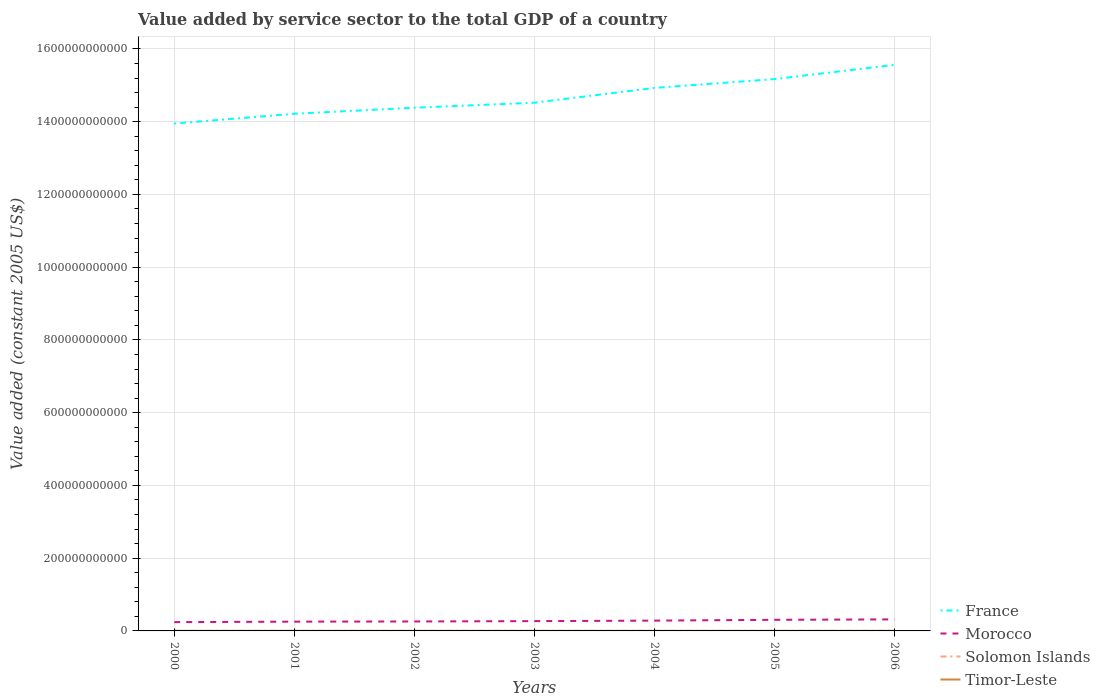Does the line corresponding to France intersect with the line corresponding to Morocco?
Make the answer very short. No. Is the number of lines equal to the number of legend labels?
Make the answer very short. Yes. Across all years, what is the maximum value added by service sector in Solomon Islands?
Provide a succinct answer. 1.94e+08. What is the total value added by service sector in France in the graph?
Your response must be concise. -5.44e+1. What is the difference between the highest and the second highest value added by service sector in Timor-Leste?
Provide a succinct answer. 7.10e+07. What is the difference between the highest and the lowest value added by service sector in France?
Your answer should be very brief. 3. How many years are there in the graph?
Make the answer very short. 7. What is the difference between two consecutive major ticks on the Y-axis?
Give a very brief answer. 2.00e+11. Does the graph contain grids?
Ensure brevity in your answer.  Yes. Where does the legend appear in the graph?
Your answer should be compact. Bottom right. How are the legend labels stacked?
Make the answer very short. Vertical. What is the title of the graph?
Give a very brief answer. Value added by service sector to the total GDP of a country. What is the label or title of the X-axis?
Your answer should be compact. Years. What is the label or title of the Y-axis?
Make the answer very short. Value added (constant 2005 US$). What is the Value added (constant 2005 US$) in France in 2000?
Keep it short and to the point. 1.39e+12. What is the Value added (constant 2005 US$) of Morocco in 2000?
Make the answer very short. 2.42e+1. What is the Value added (constant 2005 US$) of Solomon Islands in 2000?
Keep it short and to the point. 2.48e+08. What is the Value added (constant 2005 US$) of Timor-Leste in 2000?
Your response must be concise. 2.26e+08. What is the Value added (constant 2005 US$) in France in 2001?
Offer a very short reply. 1.42e+12. What is the Value added (constant 2005 US$) of Morocco in 2001?
Provide a short and direct response. 2.55e+1. What is the Value added (constant 2005 US$) in Solomon Islands in 2001?
Your answer should be very brief. 2.35e+08. What is the Value added (constant 2005 US$) of Timor-Leste in 2001?
Ensure brevity in your answer.  2.95e+08. What is the Value added (constant 2005 US$) of France in 2002?
Provide a short and direct response. 1.44e+12. What is the Value added (constant 2005 US$) in Morocco in 2002?
Give a very brief answer. 2.60e+1. What is the Value added (constant 2005 US$) of Solomon Islands in 2002?
Ensure brevity in your answer.  2.09e+08. What is the Value added (constant 2005 US$) of Timor-Leste in 2002?
Your answer should be compact. 2.65e+08. What is the Value added (constant 2005 US$) in France in 2003?
Provide a short and direct response. 1.45e+12. What is the Value added (constant 2005 US$) of Morocco in 2003?
Keep it short and to the point. 2.69e+1. What is the Value added (constant 2005 US$) of Solomon Islands in 2003?
Keep it short and to the point. 1.94e+08. What is the Value added (constant 2005 US$) of Timor-Leste in 2003?
Make the answer very short. 2.63e+08. What is the Value added (constant 2005 US$) of France in 2004?
Provide a succinct answer. 1.49e+12. What is the Value added (constant 2005 US$) in Morocco in 2004?
Provide a short and direct response. 2.83e+1. What is the Value added (constant 2005 US$) of Solomon Islands in 2004?
Ensure brevity in your answer.  2.15e+08. What is the Value added (constant 2005 US$) in Timor-Leste in 2004?
Your response must be concise. 2.73e+08. What is the Value added (constant 2005 US$) of France in 2005?
Your response must be concise. 1.52e+12. What is the Value added (constant 2005 US$) of Morocco in 2005?
Your answer should be compact. 3.05e+1. What is the Value added (constant 2005 US$) of Solomon Islands in 2005?
Your response must be concise. 2.33e+08. What is the Value added (constant 2005 US$) in Timor-Leste in 2005?
Provide a short and direct response. 2.97e+08. What is the Value added (constant 2005 US$) of France in 2006?
Offer a very short reply. 1.56e+12. What is the Value added (constant 2005 US$) of Morocco in 2006?
Your response must be concise. 3.17e+1. What is the Value added (constant 2005 US$) in Solomon Islands in 2006?
Provide a succinct answer. 2.52e+08. What is the Value added (constant 2005 US$) in Timor-Leste in 2006?
Provide a short and direct response. 2.89e+08. Across all years, what is the maximum Value added (constant 2005 US$) in France?
Keep it short and to the point. 1.56e+12. Across all years, what is the maximum Value added (constant 2005 US$) in Morocco?
Give a very brief answer. 3.17e+1. Across all years, what is the maximum Value added (constant 2005 US$) of Solomon Islands?
Offer a very short reply. 2.52e+08. Across all years, what is the maximum Value added (constant 2005 US$) of Timor-Leste?
Provide a short and direct response. 2.97e+08. Across all years, what is the minimum Value added (constant 2005 US$) of France?
Ensure brevity in your answer.  1.39e+12. Across all years, what is the minimum Value added (constant 2005 US$) in Morocco?
Give a very brief answer. 2.42e+1. Across all years, what is the minimum Value added (constant 2005 US$) in Solomon Islands?
Provide a short and direct response. 1.94e+08. Across all years, what is the minimum Value added (constant 2005 US$) in Timor-Leste?
Make the answer very short. 2.26e+08. What is the total Value added (constant 2005 US$) in France in the graph?
Offer a very short reply. 1.03e+13. What is the total Value added (constant 2005 US$) of Morocco in the graph?
Your response must be concise. 1.93e+11. What is the total Value added (constant 2005 US$) in Solomon Islands in the graph?
Provide a short and direct response. 1.59e+09. What is the total Value added (constant 2005 US$) in Timor-Leste in the graph?
Your answer should be very brief. 1.91e+09. What is the difference between the Value added (constant 2005 US$) of France in 2000 and that in 2001?
Make the answer very short. -2.69e+1. What is the difference between the Value added (constant 2005 US$) of Morocco in 2000 and that in 2001?
Make the answer very short. -1.34e+09. What is the difference between the Value added (constant 2005 US$) of Solomon Islands in 2000 and that in 2001?
Provide a succinct answer. 1.31e+07. What is the difference between the Value added (constant 2005 US$) of Timor-Leste in 2000 and that in 2001?
Ensure brevity in your answer.  -6.95e+07. What is the difference between the Value added (constant 2005 US$) in France in 2000 and that in 2002?
Provide a short and direct response. -4.36e+1. What is the difference between the Value added (constant 2005 US$) in Morocco in 2000 and that in 2002?
Offer a very short reply. -1.79e+09. What is the difference between the Value added (constant 2005 US$) of Solomon Islands in 2000 and that in 2002?
Provide a short and direct response. 3.97e+07. What is the difference between the Value added (constant 2005 US$) in Timor-Leste in 2000 and that in 2002?
Offer a terse response. -3.89e+07. What is the difference between the Value added (constant 2005 US$) of France in 2000 and that in 2003?
Ensure brevity in your answer.  -5.73e+1. What is the difference between the Value added (constant 2005 US$) of Morocco in 2000 and that in 2003?
Provide a succinct answer. -2.75e+09. What is the difference between the Value added (constant 2005 US$) of Solomon Islands in 2000 and that in 2003?
Ensure brevity in your answer.  5.41e+07. What is the difference between the Value added (constant 2005 US$) of Timor-Leste in 2000 and that in 2003?
Your response must be concise. -3.66e+07. What is the difference between the Value added (constant 2005 US$) in France in 2000 and that in 2004?
Ensure brevity in your answer.  -9.79e+1. What is the difference between the Value added (constant 2005 US$) in Morocco in 2000 and that in 2004?
Give a very brief answer. -4.18e+09. What is the difference between the Value added (constant 2005 US$) of Solomon Islands in 2000 and that in 2004?
Your response must be concise. 3.31e+07. What is the difference between the Value added (constant 2005 US$) in Timor-Leste in 2000 and that in 2004?
Your answer should be very brief. -4.66e+07. What is the difference between the Value added (constant 2005 US$) in France in 2000 and that in 2005?
Ensure brevity in your answer.  -1.22e+11. What is the difference between the Value added (constant 2005 US$) in Morocco in 2000 and that in 2005?
Keep it short and to the point. -6.36e+09. What is the difference between the Value added (constant 2005 US$) of Solomon Islands in 2000 and that in 2005?
Your answer should be very brief. 1.53e+07. What is the difference between the Value added (constant 2005 US$) of Timor-Leste in 2000 and that in 2005?
Your answer should be very brief. -7.10e+07. What is the difference between the Value added (constant 2005 US$) in France in 2000 and that in 2006?
Give a very brief answer. -1.61e+11. What is the difference between the Value added (constant 2005 US$) in Morocco in 2000 and that in 2006?
Your answer should be compact. -7.53e+09. What is the difference between the Value added (constant 2005 US$) in Solomon Islands in 2000 and that in 2006?
Give a very brief answer. -3.08e+06. What is the difference between the Value added (constant 2005 US$) of Timor-Leste in 2000 and that in 2006?
Your answer should be compact. -6.34e+07. What is the difference between the Value added (constant 2005 US$) in France in 2001 and that in 2002?
Offer a very short reply. -1.67e+1. What is the difference between the Value added (constant 2005 US$) of Morocco in 2001 and that in 2002?
Give a very brief answer. -4.57e+08. What is the difference between the Value added (constant 2005 US$) in Solomon Islands in 2001 and that in 2002?
Provide a succinct answer. 2.66e+07. What is the difference between the Value added (constant 2005 US$) in Timor-Leste in 2001 and that in 2002?
Offer a terse response. 3.05e+07. What is the difference between the Value added (constant 2005 US$) in France in 2001 and that in 2003?
Provide a short and direct response. -3.04e+1. What is the difference between the Value added (constant 2005 US$) of Morocco in 2001 and that in 2003?
Keep it short and to the point. -1.41e+09. What is the difference between the Value added (constant 2005 US$) in Solomon Islands in 2001 and that in 2003?
Provide a succinct answer. 4.10e+07. What is the difference between the Value added (constant 2005 US$) in Timor-Leste in 2001 and that in 2003?
Your answer should be very brief. 3.28e+07. What is the difference between the Value added (constant 2005 US$) of France in 2001 and that in 2004?
Ensure brevity in your answer.  -7.10e+1. What is the difference between the Value added (constant 2005 US$) in Morocco in 2001 and that in 2004?
Ensure brevity in your answer.  -2.84e+09. What is the difference between the Value added (constant 2005 US$) of Solomon Islands in 2001 and that in 2004?
Offer a terse response. 2.00e+07. What is the difference between the Value added (constant 2005 US$) of Timor-Leste in 2001 and that in 2004?
Ensure brevity in your answer.  2.29e+07. What is the difference between the Value added (constant 2005 US$) of France in 2001 and that in 2005?
Offer a very short reply. -9.54e+1. What is the difference between the Value added (constant 2005 US$) of Morocco in 2001 and that in 2005?
Your response must be concise. -5.02e+09. What is the difference between the Value added (constant 2005 US$) in Solomon Islands in 2001 and that in 2005?
Provide a short and direct response. 2.29e+06. What is the difference between the Value added (constant 2005 US$) in Timor-Leste in 2001 and that in 2005?
Your answer should be very brief. -1.53e+06. What is the difference between the Value added (constant 2005 US$) of France in 2001 and that in 2006?
Offer a very short reply. -1.34e+11. What is the difference between the Value added (constant 2005 US$) of Morocco in 2001 and that in 2006?
Your answer should be compact. -6.20e+09. What is the difference between the Value added (constant 2005 US$) in Solomon Islands in 2001 and that in 2006?
Provide a succinct answer. -1.61e+07. What is the difference between the Value added (constant 2005 US$) in Timor-Leste in 2001 and that in 2006?
Your response must be concise. 6.11e+06. What is the difference between the Value added (constant 2005 US$) of France in 2002 and that in 2003?
Provide a succinct answer. -1.37e+1. What is the difference between the Value added (constant 2005 US$) of Morocco in 2002 and that in 2003?
Your answer should be compact. -9.53e+08. What is the difference between the Value added (constant 2005 US$) of Solomon Islands in 2002 and that in 2003?
Keep it short and to the point. 1.44e+07. What is the difference between the Value added (constant 2005 US$) in Timor-Leste in 2002 and that in 2003?
Give a very brief answer. 2.29e+06. What is the difference between the Value added (constant 2005 US$) in France in 2002 and that in 2004?
Offer a terse response. -5.44e+1. What is the difference between the Value added (constant 2005 US$) of Morocco in 2002 and that in 2004?
Your answer should be compact. -2.38e+09. What is the difference between the Value added (constant 2005 US$) in Solomon Islands in 2002 and that in 2004?
Provide a short and direct response. -6.61e+06. What is the difference between the Value added (constant 2005 US$) in Timor-Leste in 2002 and that in 2004?
Your answer should be compact. -7.63e+06. What is the difference between the Value added (constant 2005 US$) in France in 2002 and that in 2005?
Your answer should be very brief. -7.87e+1. What is the difference between the Value added (constant 2005 US$) in Morocco in 2002 and that in 2005?
Your answer should be compact. -4.56e+09. What is the difference between the Value added (constant 2005 US$) of Solomon Islands in 2002 and that in 2005?
Make the answer very short. -2.43e+07. What is the difference between the Value added (constant 2005 US$) of Timor-Leste in 2002 and that in 2005?
Provide a succinct answer. -3.21e+07. What is the difference between the Value added (constant 2005 US$) in France in 2002 and that in 2006?
Your answer should be very brief. -1.18e+11. What is the difference between the Value added (constant 2005 US$) in Morocco in 2002 and that in 2006?
Provide a succinct answer. -5.74e+09. What is the difference between the Value added (constant 2005 US$) in Solomon Islands in 2002 and that in 2006?
Ensure brevity in your answer.  -4.28e+07. What is the difference between the Value added (constant 2005 US$) of Timor-Leste in 2002 and that in 2006?
Your response must be concise. -2.44e+07. What is the difference between the Value added (constant 2005 US$) in France in 2003 and that in 2004?
Your response must be concise. -4.07e+1. What is the difference between the Value added (constant 2005 US$) of Morocco in 2003 and that in 2004?
Provide a short and direct response. -1.43e+09. What is the difference between the Value added (constant 2005 US$) of Solomon Islands in 2003 and that in 2004?
Give a very brief answer. -2.10e+07. What is the difference between the Value added (constant 2005 US$) of Timor-Leste in 2003 and that in 2004?
Your response must be concise. -9.93e+06. What is the difference between the Value added (constant 2005 US$) of France in 2003 and that in 2005?
Your answer should be compact. -6.50e+1. What is the difference between the Value added (constant 2005 US$) of Morocco in 2003 and that in 2005?
Offer a terse response. -3.61e+09. What is the difference between the Value added (constant 2005 US$) of Solomon Islands in 2003 and that in 2005?
Your answer should be very brief. -3.87e+07. What is the difference between the Value added (constant 2005 US$) in Timor-Leste in 2003 and that in 2005?
Offer a terse response. -3.44e+07. What is the difference between the Value added (constant 2005 US$) in France in 2003 and that in 2006?
Offer a terse response. -1.04e+11. What is the difference between the Value added (constant 2005 US$) in Morocco in 2003 and that in 2006?
Provide a succinct answer. -4.79e+09. What is the difference between the Value added (constant 2005 US$) of Solomon Islands in 2003 and that in 2006?
Your answer should be compact. -5.72e+07. What is the difference between the Value added (constant 2005 US$) of Timor-Leste in 2003 and that in 2006?
Ensure brevity in your answer.  -2.67e+07. What is the difference between the Value added (constant 2005 US$) of France in 2004 and that in 2005?
Your answer should be compact. -2.43e+1. What is the difference between the Value added (constant 2005 US$) of Morocco in 2004 and that in 2005?
Keep it short and to the point. -2.18e+09. What is the difference between the Value added (constant 2005 US$) in Solomon Islands in 2004 and that in 2005?
Keep it short and to the point. -1.77e+07. What is the difference between the Value added (constant 2005 US$) in Timor-Leste in 2004 and that in 2005?
Keep it short and to the point. -2.44e+07. What is the difference between the Value added (constant 2005 US$) of France in 2004 and that in 2006?
Your answer should be very brief. -6.34e+1. What is the difference between the Value added (constant 2005 US$) in Morocco in 2004 and that in 2006?
Keep it short and to the point. -3.36e+09. What is the difference between the Value added (constant 2005 US$) of Solomon Islands in 2004 and that in 2006?
Provide a succinct answer. -3.62e+07. What is the difference between the Value added (constant 2005 US$) in Timor-Leste in 2004 and that in 2006?
Offer a very short reply. -1.68e+07. What is the difference between the Value added (constant 2005 US$) of France in 2005 and that in 2006?
Your response must be concise. -3.91e+1. What is the difference between the Value added (constant 2005 US$) in Morocco in 2005 and that in 2006?
Your answer should be very brief. -1.18e+09. What is the difference between the Value added (constant 2005 US$) in Solomon Islands in 2005 and that in 2006?
Provide a succinct answer. -1.84e+07. What is the difference between the Value added (constant 2005 US$) in Timor-Leste in 2005 and that in 2006?
Give a very brief answer. 7.63e+06. What is the difference between the Value added (constant 2005 US$) in France in 2000 and the Value added (constant 2005 US$) in Morocco in 2001?
Offer a terse response. 1.37e+12. What is the difference between the Value added (constant 2005 US$) in France in 2000 and the Value added (constant 2005 US$) in Solomon Islands in 2001?
Provide a short and direct response. 1.39e+12. What is the difference between the Value added (constant 2005 US$) in France in 2000 and the Value added (constant 2005 US$) in Timor-Leste in 2001?
Keep it short and to the point. 1.39e+12. What is the difference between the Value added (constant 2005 US$) of Morocco in 2000 and the Value added (constant 2005 US$) of Solomon Islands in 2001?
Your response must be concise. 2.39e+1. What is the difference between the Value added (constant 2005 US$) of Morocco in 2000 and the Value added (constant 2005 US$) of Timor-Leste in 2001?
Ensure brevity in your answer.  2.39e+1. What is the difference between the Value added (constant 2005 US$) in Solomon Islands in 2000 and the Value added (constant 2005 US$) in Timor-Leste in 2001?
Your answer should be very brief. -4.70e+07. What is the difference between the Value added (constant 2005 US$) of France in 2000 and the Value added (constant 2005 US$) of Morocco in 2002?
Provide a succinct answer. 1.37e+12. What is the difference between the Value added (constant 2005 US$) in France in 2000 and the Value added (constant 2005 US$) in Solomon Islands in 2002?
Your answer should be compact. 1.39e+12. What is the difference between the Value added (constant 2005 US$) in France in 2000 and the Value added (constant 2005 US$) in Timor-Leste in 2002?
Offer a terse response. 1.39e+12. What is the difference between the Value added (constant 2005 US$) of Morocco in 2000 and the Value added (constant 2005 US$) of Solomon Islands in 2002?
Provide a succinct answer. 2.40e+1. What is the difference between the Value added (constant 2005 US$) of Morocco in 2000 and the Value added (constant 2005 US$) of Timor-Leste in 2002?
Ensure brevity in your answer.  2.39e+1. What is the difference between the Value added (constant 2005 US$) of Solomon Islands in 2000 and the Value added (constant 2005 US$) of Timor-Leste in 2002?
Make the answer very short. -1.64e+07. What is the difference between the Value added (constant 2005 US$) in France in 2000 and the Value added (constant 2005 US$) in Morocco in 2003?
Your answer should be compact. 1.37e+12. What is the difference between the Value added (constant 2005 US$) of France in 2000 and the Value added (constant 2005 US$) of Solomon Islands in 2003?
Your answer should be very brief. 1.39e+12. What is the difference between the Value added (constant 2005 US$) of France in 2000 and the Value added (constant 2005 US$) of Timor-Leste in 2003?
Give a very brief answer. 1.39e+12. What is the difference between the Value added (constant 2005 US$) of Morocco in 2000 and the Value added (constant 2005 US$) of Solomon Islands in 2003?
Your answer should be very brief. 2.40e+1. What is the difference between the Value added (constant 2005 US$) in Morocco in 2000 and the Value added (constant 2005 US$) in Timor-Leste in 2003?
Provide a short and direct response. 2.39e+1. What is the difference between the Value added (constant 2005 US$) of Solomon Islands in 2000 and the Value added (constant 2005 US$) of Timor-Leste in 2003?
Make the answer very short. -1.41e+07. What is the difference between the Value added (constant 2005 US$) of France in 2000 and the Value added (constant 2005 US$) of Morocco in 2004?
Keep it short and to the point. 1.37e+12. What is the difference between the Value added (constant 2005 US$) of France in 2000 and the Value added (constant 2005 US$) of Solomon Islands in 2004?
Your response must be concise. 1.39e+12. What is the difference between the Value added (constant 2005 US$) in France in 2000 and the Value added (constant 2005 US$) in Timor-Leste in 2004?
Make the answer very short. 1.39e+12. What is the difference between the Value added (constant 2005 US$) of Morocco in 2000 and the Value added (constant 2005 US$) of Solomon Islands in 2004?
Provide a succinct answer. 2.40e+1. What is the difference between the Value added (constant 2005 US$) in Morocco in 2000 and the Value added (constant 2005 US$) in Timor-Leste in 2004?
Your response must be concise. 2.39e+1. What is the difference between the Value added (constant 2005 US$) in Solomon Islands in 2000 and the Value added (constant 2005 US$) in Timor-Leste in 2004?
Offer a terse response. -2.41e+07. What is the difference between the Value added (constant 2005 US$) of France in 2000 and the Value added (constant 2005 US$) of Morocco in 2005?
Offer a very short reply. 1.36e+12. What is the difference between the Value added (constant 2005 US$) in France in 2000 and the Value added (constant 2005 US$) in Solomon Islands in 2005?
Ensure brevity in your answer.  1.39e+12. What is the difference between the Value added (constant 2005 US$) of France in 2000 and the Value added (constant 2005 US$) of Timor-Leste in 2005?
Ensure brevity in your answer.  1.39e+12. What is the difference between the Value added (constant 2005 US$) of Morocco in 2000 and the Value added (constant 2005 US$) of Solomon Islands in 2005?
Your answer should be very brief. 2.39e+1. What is the difference between the Value added (constant 2005 US$) of Morocco in 2000 and the Value added (constant 2005 US$) of Timor-Leste in 2005?
Your answer should be very brief. 2.39e+1. What is the difference between the Value added (constant 2005 US$) of Solomon Islands in 2000 and the Value added (constant 2005 US$) of Timor-Leste in 2005?
Your answer should be compact. -4.85e+07. What is the difference between the Value added (constant 2005 US$) in France in 2000 and the Value added (constant 2005 US$) in Morocco in 2006?
Your answer should be very brief. 1.36e+12. What is the difference between the Value added (constant 2005 US$) of France in 2000 and the Value added (constant 2005 US$) of Solomon Islands in 2006?
Keep it short and to the point. 1.39e+12. What is the difference between the Value added (constant 2005 US$) of France in 2000 and the Value added (constant 2005 US$) of Timor-Leste in 2006?
Your answer should be very brief. 1.39e+12. What is the difference between the Value added (constant 2005 US$) of Morocco in 2000 and the Value added (constant 2005 US$) of Solomon Islands in 2006?
Ensure brevity in your answer.  2.39e+1. What is the difference between the Value added (constant 2005 US$) of Morocco in 2000 and the Value added (constant 2005 US$) of Timor-Leste in 2006?
Offer a very short reply. 2.39e+1. What is the difference between the Value added (constant 2005 US$) of Solomon Islands in 2000 and the Value added (constant 2005 US$) of Timor-Leste in 2006?
Make the answer very short. -4.09e+07. What is the difference between the Value added (constant 2005 US$) in France in 2001 and the Value added (constant 2005 US$) in Morocco in 2002?
Make the answer very short. 1.40e+12. What is the difference between the Value added (constant 2005 US$) in France in 2001 and the Value added (constant 2005 US$) in Solomon Islands in 2002?
Offer a very short reply. 1.42e+12. What is the difference between the Value added (constant 2005 US$) of France in 2001 and the Value added (constant 2005 US$) of Timor-Leste in 2002?
Your answer should be compact. 1.42e+12. What is the difference between the Value added (constant 2005 US$) of Morocco in 2001 and the Value added (constant 2005 US$) of Solomon Islands in 2002?
Give a very brief answer. 2.53e+1. What is the difference between the Value added (constant 2005 US$) of Morocco in 2001 and the Value added (constant 2005 US$) of Timor-Leste in 2002?
Your answer should be very brief. 2.52e+1. What is the difference between the Value added (constant 2005 US$) of Solomon Islands in 2001 and the Value added (constant 2005 US$) of Timor-Leste in 2002?
Keep it short and to the point. -2.95e+07. What is the difference between the Value added (constant 2005 US$) of France in 2001 and the Value added (constant 2005 US$) of Morocco in 2003?
Provide a short and direct response. 1.39e+12. What is the difference between the Value added (constant 2005 US$) of France in 2001 and the Value added (constant 2005 US$) of Solomon Islands in 2003?
Give a very brief answer. 1.42e+12. What is the difference between the Value added (constant 2005 US$) in France in 2001 and the Value added (constant 2005 US$) in Timor-Leste in 2003?
Your answer should be very brief. 1.42e+12. What is the difference between the Value added (constant 2005 US$) in Morocco in 2001 and the Value added (constant 2005 US$) in Solomon Islands in 2003?
Your answer should be compact. 2.53e+1. What is the difference between the Value added (constant 2005 US$) of Morocco in 2001 and the Value added (constant 2005 US$) of Timor-Leste in 2003?
Your answer should be very brief. 2.52e+1. What is the difference between the Value added (constant 2005 US$) in Solomon Islands in 2001 and the Value added (constant 2005 US$) in Timor-Leste in 2003?
Your answer should be compact. -2.72e+07. What is the difference between the Value added (constant 2005 US$) in France in 2001 and the Value added (constant 2005 US$) in Morocco in 2004?
Offer a very short reply. 1.39e+12. What is the difference between the Value added (constant 2005 US$) in France in 2001 and the Value added (constant 2005 US$) in Solomon Islands in 2004?
Your response must be concise. 1.42e+12. What is the difference between the Value added (constant 2005 US$) of France in 2001 and the Value added (constant 2005 US$) of Timor-Leste in 2004?
Ensure brevity in your answer.  1.42e+12. What is the difference between the Value added (constant 2005 US$) in Morocco in 2001 and the Value added (constant 2005 US$) in Solomon Islands in 2004?
Provide a short and direct response. 2.53e+1. What is the difference between the Value added (constant 2005 US$) in Morocco in 2001 and the Value added (constant 2005 US$) in Timor-Leste in 2004?
Your response must be concise. 2.52e+1. What is the difference between the Value added (constant 2005 US$) in Solomon Islands in 2001 and the Value added (constant 2005 US$) in Timor-Leste in 2004?
Ensure brevity in your answer.  -3.71e+07. What is the difference between the Value added (constant 2005 US$) of France in 2001 and the Value added (constant 2005 US$) of Morocco in 2005?
Your answer should be compact. 1.39e+12. What is the difference between the Value added (constant 2005 US$) of France in 2001 and the Value added (constant 2005 US$) of Solomon Islands in 2005?
Your answer should be very brief. 1.42e+12. What is the difference between the Value added (constant 2005 US$) of France in 2001 and the Value added (constant 2005 US$) of Timor-Leste in 2005?
Offer a terse response. 1.42e+12. What is the difference between the Value added (constant 2005 US$) in Morocco in 2001 and the Value added (constant 2005 US$) in Solomon Islands in 2005?
Your response must be concise. 2.53e+1. What is the difference between the Value added (constant 2005 US$) in Morocco in 2001 and the Value added (constant 2005 US$) in Timor-Leste in 2005?
Offer a terse response. 2.52e+1. What is the difference between the Value added (constant 2005 US$) of Solomon Islands in 2001 and the Value added (constant 2005 US$) of Timor-Leste in 2005?
Your answer should be compact. -6.16e+07. What is the difference between the Value added (constant 2005 US$) of France in 2001 and the Value added (constant 2005 US$) of Morocco in 2006?
Ensure brevity in your answer.  1.39e+12. What is the difference between the Value added (constant 2005 US$) in France in 2001 and the Value added (constant 2005 US$) in Solomon Islands in 2006?
Make the answer very short. 1.42e+12. What is the difference between the Value added (constant 2005 US$) of France in 2001 and the Value added (constant 2005 US$) of Timor-Leste in 2006?
Offer a terse response. 1.42e+12. What is the difference between the Value added (constant 2005 US$) in Morocco in 2001 and the Value added (constant 2005 US$) in Solomon Islands in 2006?
Give a very brief answer. 2.53e+1. What is the difference between the Value added (constant 2005 US$) in Morocco in 2001 and the Value added (constant 2005 US$) in Timor-Leste in 2006?
Your answer should be very brief. 2.52e+1. What is the difference between the Value added (constant 2005 US$) of Solomon Islands in 2001 and the Value added (constant 2005 US$) of Timor-Leste in 2006?
Provide a succinct answer. -5.39e+07. What is the difference between the Value added (constant 2005 US$) in France in 2002 and the Value added (constant 2005 US$) in Morocco in 2003?
Provide a short and direct response. 1.41e+12. What is the difference between the Value added (constant 2005 US$) of France in 2002 and the Value added (constant 2005 US$) of Solomon Islands in 2003?
Your response must be concise. 1.44e+12. What is the difference between the Value added (constant 2005 US$) of France in 2002 and the Value added (constant 2005 US$) of Timor-Leste in 2003?
Keep it short and to the point. 1.44e+12. What is the difference between the Value added (constant 2005 US$) of Morocco in 2002 and the Value added (constant 2005 US$) of Solomon Islands in 2003?
Your answer should be compact. 2.58e+1. What is the difference between the Value added (constant 2005 US$) of Morocco in 2002 and the Value added (constant 2005 US$) of Timor-Leste in 2003?
Make the answer very short. 2.57e+1. What is the difference between the Value added (constant 2005 US$) in Solomon Islands in 2002 and the Value added (constant 2005 US$) in Timor-Leste in 2003?
Your response must be concise. -5.38e+07. What is the difference between the Value added (constant 2005 US$) of France in 2002 and the Value added (constant 2005 US$) of Morocco in 2004?
Provide a short and direct response. 1.41e+12. What is the difference between the Value added (constant 2005 US$) in France in 2002 and the Value added (constant 2005 US$) in Solomon Islands in 2004?
Offer a very short reply. 1.44e+12. What is the difference between the Value added (constant 2005 US$) in France in 2002 and the Value added (constant 2005 US$) in Timor-Leste in 2004?
Ensure brevity in your answer.  1.44e+12. What is the difference between the Value added (constant 2005 US$) of Morocco in 2002 and the Value added (constant 2005 US$) of Solomon Islands in 2004?
Your response must be concise. 2.58e+1. What is the difference between the Value added (constant 2005 US$) of Morocco in 2002 and the Value added (constant 2005 US$) of Timor-Leste in 2004?
Keep it short and to the point. 2.57e+1. What is the difference between the Value added (constant 2005 US$) of Solomon Islands in 2002 and the Value added (constant 2005 US$) of Timor-Leste in 2004?
Your response must be concise. -6.38e+07. What is the difference between the Value added (constant 2005 US$) of France in 2002 and the Value added (constant 2005 US$) of Morocco in 2005?
Your answer should be compact. 1.41e+12. What is the difference between the Value added (constant 2005 US$) of France in 2002 and the Value added (constant 2005 US$) of Solomon Islands in 2005?
Offer a very short reply. 1.44e+12. What is the difference between the Value added (constant 2005 US$) of France in 2002 and the Value added (constant 2005 US$) of Timor-Leste in 2005?
Make the answer very short. 1.44e+12. What is the difference between the Value added (constant 2005 US$) in Morocco in 2002 and the Value added (constant 2005 US$) in Solomon Islands in 2005?
Keep it short and to the point. 2.57e+1. What is the difference between the Value added (constant 2005 US$) of Morocco in 2002 and the Value added (constant 2005 US$) of Timor-Leste in 2005?
Offer a very short reply. 2.57e+1. What is the difference between the Value added (constant 2005 US$) in Solomon Islands in 2002 and the Value added (constant 2005 US$) in Timor-Leste in 2005?
Offer a very short reply. -8.82e+07. What is the difference between the Value added (constant 2005 US$) in France in 2002 and the Value added (constant 2005 US$) in Morocco in 2006?
Ensure brevity in your answer.  1.41e+12. What is the difference between the Value added (constant 2005 US$) in France in 2002 and the Value added (constant 2005 US$) in Solomon Islands in 2006?
Provide a short and direct response. 1.44e+12. What is the difference between the Value added (constant 2005 US$) of France in 2002 and the Value added (constant 2005 US$) of Timor-Leste in 2006?
Provide a short and direct response. 1.44e+12. What is the difference between the Value added (constant 2005 US$) of Morocco in 2002 and the Value added (constant 2005 US$) of Solomon Islands in 2006?
Your answer should be very brief. 2.57e+1. What is the difference between the Value added (constant 2005 US$) in Morocco in 2002 and the Value added (constant 2005 US$) in Timor-Leste in 2006?
Offer a terse response. 2.57e+1. What is the difference between the Value added (constant 2005 US$) in Solomon Islands in 2002 and the Value added (constant 2005 US$) in Timor-Leste in 2006?
Offer a very short reply. -8.06e+07. What is the difference between the Value added (constant 2005 US$) in France in 2003 and the Value added (constant 2005 US$) in Morocco in 2004?
Keep it short and to the point. 1.42e+12. What is the difference between the Value added (constant 2005 US$) in France in 2003 and the Value added (constant 2005 US$) in Solomon Islands in 2004?
Keep it short and to the point. 1.45e+12. What is the difference between the Value added (constant 2005 US$) in France in 2003 and the Value added (constant 2005 US$) in Timor-Leste in 2004?
Give a very brief answer. 1.45e+12. What is the difference between the Value added (constant 2005 US$) of Morocco in 2003 and the Value added (constant 2005 US$) of Solomon Islands in 2004?
Give a very brief answer. 2.67e+1. What is the difference between the Value added (constant 2005 US$) of Morocco in 2003 and the Value added (constant 2005 US$) of Timor-Leste in 2004?
Your answer should be very brief. 2.66e+1. What is the difference between the Value added (constant 2005 US$) in Solomon Islands in 2003 and the Value added (constant 2005 US$) in Timor-Leste in 2004?
Make the answer very short. -7.82e+07. What is the difference between the Value added (constant 2005 US$) of France in 2003 and the Value added (constant 2005 US$) of Morocco in 2005?
Your response must be concise. 1.42e+12. What is the difference between the Value added (constant 2005 US$) in France in 2003 and the Value added (constant 2005 US$) in Solomon Islands in 2005?
Give a very brief answer. 1.45e+12. What is the difference between the Value added (constant 2005 US$) in France in 2003 and the Value added (constant 2005 US$) in Timor-Leste in 2005?
Provide a short and direct response. 1.45e+12. What is the difference between the Value added (constant 2005 US$) of Morocco in 2003 and the Value added (constant 2005 US$) of Solomon Islands in 2005?
Make the answer very short. 2.67e+1. What is the difference between the Value added (constant 2005 US$) in Morocco in 2003 and the Value added (constant 2005 US$) in Timor-Leste in 2005?
Your answer should be compact. 2.66e+1. What is the difference between the Value added (constant 2005 US$) of Solomon Islands in 2003 and the Value added (constant 2005 US$) of Timor-Leste in 2005?
Provide a succinct answer. -1.03e+08. What is the difference between the Value added (constant 2005 US$) of France in 2003 and the Value added (constant 2005 US$) of Morocco in 2006?
Your answer should be compact. 1.42e+12. What is the difference between the Value added (constant 2005 US$) in France in 2003 and the Value added (constant 2005 US$) in Solomon Islands in 2006?
Your response must be concise. 1.45e+12. What is the difference between the Value added (constant 2005 US$) of France in 2003 and the Value added (constant 2005 US$) of Timor-Leste in 2006?
Offer a very short reply. 1.45e+12. What is the difference between the Value added (constant 2005 US$) of Morocco in 2003 and the Value added (constant 2005 US$) of Solomon Islands in 2006?
Offer a terse response. 2.67e+1. What is the difference between the Value added (constant 2005 US$) of Morocco in 2003 and the Value added (constant 2005 US$) of Timor-Leste in 2006?
Your answer should be compact. 2.66e+1. What is the difference between the Value added (constant 2005 US$) of Solomon Islands in 2003 and the Value added (constant 2005 US$) of Timor-Leste in 2006?
Your answer should be very brief. -9.49e+07. What is the difference between the Value added (constant 2005 US$) in France in 2004 and the Value added (constant 2005 US$) in Morocco in 2005?
Keep it short and to the point. 1.46e+12. What is the difference between the Value added (constant 2005 US$) in France in 2004 and the Value added (constant 2005 US$) in Solomon Islands in 2005?
Ensure brevity in your answer.  1.49e+12. What is the difference between the Value added (constant 2005 US$) in France in 2004 and the Value added (constant 2005 US$) in Timor-Leste in 2005?
Give a very brief answer. 1.49e+12. What is the difference between the Value added (constant 2005 US$) in Morocco in 2004 and the Value added (constant 2005 US$) in Solomon Islands in 2005?
Keep it short and to the point. 2.81e+1. What is the difference between the Value added (constant 2005 US$) in Morocco in 2004 and the Value added (constant 2005 US$) in Timor-Leste in 2005?
Offer a terse response. 2.81e+1. What is the difference between the Value added (constant 2005 US$) of Solomon Islands in 2004 and the Value added (constant 2005 US$) of Timor-Leste in 2005?
Offer a terse response. -8.16e+07. What is the difference between the Value added (constant 2005 US$) in France in 2004 and the Value added (constant 2005 US$) in Morocco in 2006?
Your answer should be very brief. 1.46e+12. What is the difference between the Value added (constant 2005 US$) of France in 2004 and the Value added (constant 2005 US$) of Solomon Islands in 2006?
Your answer should be very brief. 1.49e+12. What is the difference between the Value added (constant 2005 US$) in France in 2004 and the Value added (constant 2005 US$) in Timor-Leste in 2006?
Offer a terse response. 1.49e+12. What is the difference between the Value added (constant 2005 US$) of Morocco in 2004 and the Value added (constant 2005 US$) of Solomon Islands in 2006?
Offer a very short reply. 2.81e+1. What is the difference between the Value added (constant 2005 US$) of Morocco in 2004 and the Value added (constant 2005 US$) of Timor-Leste in 2006?
Your answer should be compact. 2.81e+1. What is the difference between the Value added (constant 2005 US$) in Solomon Islands in 2004 and the Value added (constant 2005 US$) in Timor-Leste in 2006?
Provide a short and direct response. -7.39e+07. What is the difference between the Value added (constant 2005 US$) of France in 2005 and the Value added (constant 2005 US$) of Morocco in 2006?
Offer a terse response. 1.49e+12. What is the difference between the Value added (constant 2005 US$) in France in 2005 and the Value added (constant 2005 US$) in Solomon Islands in 2006?
Keep it short and to the point. 1.52e+12. What is the difference between the Value added (constant 2005 US$) in France in 2005 and the Value added (constant 2005 US$) in Timor-Leste in 2006?
Offer a terse response. 1.52e+12. What is the difference between the Value added (constant 2005 US$) of Morocco in 2005 and the Value added (constant 2005 US$) of Solomon Islands in 2006?
Your answer should be compact. 3.03e+1. What is the difference between the Value added (constant 2005 US$) in Morocco in 2005 and the Value added (constant 2005 US$) in Timor-Leste in 2006?
Ensure brevity in your answer.  3.02e+1. What is the difference between the Value added (constant 2005 US$) of Solomon Islands in 2005 and the Value added (constant 2005 US$) of Timor-Leste in 2006?
Make the answer very short. -5.62e+07. What is the average Value added (constant 2005 US$) in France per year?
Your answer should be very brief. 1.47e+12. What is the average Value added (constant 2005 US$) of Morocco per year?
Give a very brief answer. 2.76e+1. What is the average Value added (constant 2005 US$) in Solomon Islands per year?
Provide a short and direct response. 2.27e+08. What is the average Value added (constant 2005 US$) in Timor-Leste per year?
Keep it short and to the point. 2.73e+08. In the year 2000, what is the difference between the Value added (constant 2005 US$) in France and Value added (constant 2005 US$) in Morocco?
Your response must be concise. 1.37e+12. In the year 2000, what is the difference between the Value added (constant 2005 US$) of France and Value added (constant 2005 US$) of Solomon Islands?
Give a very brief answer. 1.39e+12. In the year 2000, what is the difference between the Value added (constant 2005 US$) in France and Value added (constant 2005 US$) in Timor-Leste?
Offer a very short reply. 1.39e+12. In the year 2000, what is the difference between the Value added (constant 2005 US$) in Morocco and Value added (constant 2005 US$) in Solomon Islands?
Your response must be concise. 2.39e+1. In the year 2000, what is the difference between the Value added (constant 2005 US$) of Morocco and Value added (constant 2005 US$) of Timor-Leste?
Provide a short and direct response. 2.39e+1. In the year 2000, what is the difference between the Value added (constant 2005 US$) in Solomon Islands and Value added (constant 2005 US$) in Timor-Leste?
Make the answer very short. 2.25e+07. In the year 2001, what is the difference between the Value added (constant 2005 US$) of France and Value added (constant 2005 US$) of Morocco?
Keep it short and to the point. 1.40e+12. In the year 2001, what is the difference between the Value added (constant 2005 US$) of France and Value added (constant 2005 US$) of Solomon Islands?
Your response must be concise. 1.42e+12. In the year 2001, what is the difference between the Value added (constant 2005 US$) of France and Value added (constant 2005 US$) of Timor-Leste?
Keep it short and to the point. 1.42e+12. In the year 2001, what is the difference between the Value added (constant 2005 US$) of Morocco and Value added (constant 2005 US$) of Solomon Islands?
Give a very brief answer. 2.53e+1. In the year 2001, what is the difference between the Value added (constant 2005 US$) of Morocco and Value added (constant 2005 US$) of Timor-Leste?
Make the answer very short. 2.52e+1. In the year 2001, what is the difference between the Value added (constant 2005 US$) in Solomon Islands and Value added (constant 2005 US$) in Timor-Leste?
Offer a terse response. -6.00e+07. In the year 2002, what is the difference between the Value added (constant 2005 US$) of France and Value added (constant 2005 US$) of Morocco?
Provide a succinct answer. 1.41e+12. In the year 2002, what is the difference between the Value added (constant 2005 US$) in France and Value added (constant 2005 US$) in Solomon Islands?
Your answer should be very brief. 1.44e+12. In the year 2002, what is the difference between the Value added (constant 2005 US$) in France and Value added (constant 2005 US$) in Timor-Leste?
Make the answer very short. 1.44e+12. In the year 2002, what is the difference between the Value added (constant 2005 US$) in Morocco and Value added (constant 2005 US$) in Solomon Islands?
Make the answer very short. 2.58e+1. In the year 2002, what is the difference between the Value added (constant 2005 US$) of Morocco and Value added (constant 2005 US$) of Timor-Leste?
Offer a terse response. 2.57e+1. In the year 2002, what is the difference between the Value added (constant 2005 US$) of Solomon Islands and Value added (constant 2005 US$) of Timor-Leste?
Provide a succinct answer. -5.61e+07. In the year 2003, what is the difference between the Value added (constant 2005 US$) in France and Value added (constant 2005 US$) in Morocco?
Offer a terse response. 1.43e+12. In the year 2003, what is the difference between the Value added (constant 2005 US$) of France and Value added (constant 2005 US$) of Solomon Islands?
Your answer should be compact. 1.45e+12. In the year 2003, what is the difference between the Value added (constant 2005 US$) of France and Value added (constant 2005 US$) of Timor-Leste?
Make the answer very short. 1.45e+12. In the year 2003, what is the difference between the Value added (constant 2005 US$) of Morocco and Value added (constant 2005 US$) of Solomon Islands?
Your response must be concise. 2.67e+1. In the year 2003, what is the difference between the Value added (constant 2005 US$) of Morocco and Value added (constant 2005 US$) of Timor-Leste?
Provide a short and direct response. 2.67e+1. In the year 2003, what is the difference between the Value added (constant 2005 US$) in Solomon Islands and Value added (constant 2005 US$) in Timor-Leste?
Offer a terse response. -6.82e+07. In the year 2004, what is the difference between the Value added (constant 2005 US$) of France and Value added (constant 2005 US$) of Morocco?
Give a very brief answer. 1.46e+12. In the year 2004, what is the difference between the Value added (constant 2005 US$) in France and Value added (constant 2005 US$) in Solomon Islands?
Your answer should be compact. 1.49e+12. In the year 2004, what is the difference between the Value added (constant 2005 US$) of France and Value added (constant 2005 US$) of Timor-Leste?
Offer a very short reply. 1.49e+12. In the year 2004, what is the difference between the Value added (constant 2005 US$) of Morocco and Value added (constant 2005 US$) of Solomon Islands?
Your answer should be compact. 2.81e+1. In the year 2004, what is the difference between the Value added (constant 2005 US$) of Morocco and Value added (constant 2005 US$) of Timor-Leste?
Offer a very short reply. 2.81e+1. In the year 2004, what is the difference between the Value added (constant 2005 US$) of Solomon Islands and Value added (constant 2005 US$) of Timor-Leste?
Your answer should be very brief. -5.72e+07. In the year 2005, what is the difference between the Value added (constant 2005 US$) in France and Value added (constant 2005 US$) in Morocco?
Your answer should be compact. 1.49e+12. In the year 2005, what is the difference between the Value added (constant 2005 US$) in France and Value added (constant 2005 US$) in Solomon Islands?
Give a very brief answer. 1.52e+12. In the year 2005, what is the difference between the Value added (constant 2005 US$) in France and Value added (constant 2005 US$) in Timor-Leste?
Your answer should be compact. 1.52e+12. In the year 2005, what is the difference between the Value added (constant 2005 US$) of Morocco and Value added (constant 2005 US$) of Solomon Islands?
Provide a succinct answer. 3.03e+1. In the year 2005, what is the difference between the Value added (constant 2005 US$) of Morocco and Value added (constant 2005 US$) of Timor-Leste?
Offer a very short reply. 3.02e+1. In the year 2005, what is the difference between the Value added (constant 2005 US$) of Solomon Islands and Value added (constant 2005 US$) of Timor-Leste?
Make the answer very short. -6.38e+07. In the year 2006, what is the difference between the Value added (constant 2005 US$) of France and Value added (constant 2005 US$) of Morocco?
Provide a short and direct response. 1.52e+12. In the year 2006, what is the difference between the Value added (constant 2005 US$) of France and Value added (constant 2005 US$) of Solomon Islands?
Keep it short and to the point. 1.56e+12. In the year 2006, what is the difference between the Value added (constant 2005 US$) in France and Value added (constant 2005 US$) in Timor-Leste?
Offer a very short reply. 1.56e+12. In the year 2006, what is the difference between the Value added (constant 2005 US$) in Morocco and Value added (constant 2005 US$) in Solomon Islands?
Your answer should be very brief. 3.15e+1. In the year 2006, what is the difference between the Value added (constant 2005 US$) of Morocco and Value added (constant 2005 US$) of Timor-Leste?
Give a very brief answer. 3.14e+1. In the year 2006, what is the difference between the Value added (constant 2005 US$) of Solomon Islands and Value added (constant 2005 US$) of Timor-Leste?
Ensure brevity in your answer.  -3.78e+07. What is the ratio of the Value added (constant 2005 US$) in France in 2000 to that in 2001?
Your answer should be very brief. 0.98. What is the ratio of the Value added (constant 2005 US$) of Morocco in 2000 to that in 2001?
Provide a succinct answer. 0.95. What is the ratio of the Value added (constant 2005 US$) in Solomon Islands in 2000 to that in 2001?
Make the answer very short. 1.06. What is the ratio of the Value added (constant 2005 US$) of Timor-Leste in 2000 to that in 2001?
Keep it short and to the point. 0.76. What is the ratio of the Value added (constant 2005 US$) in France in 2000 to that in 2002?
Provide a short and direct response. 0.97. What is the ratio of the Value added (constant 2005 US$) in Morocco in 2000 to that in 2002?
Your answer should be compact. 0.93. What is the ratio of the Value added (constant 2005 US$) in Solomon Islands in 2000 to that in 2002?
Your answer should be very brief. 1.19. What is the ratio of the Value added (constant 2005 US$) of Timor-Leste in 2000 to that in 2002?
Provide a succinct answer. 0.85. What is the ratio of the Value added (constant 2005 US$) in France in 2000 to that in 2003?
Your response must be concise. 0.96. What is the ratio of the Value added (constant 2005 US$) of Morocco in 2000 to that in 2003?
Your answer should be compact. 0.9. What is the ratio of the Value added (constant 2005 US$) in Solomon Islands in 2000 to that in 2003?
Make the answer very short. 1.28. What is the ratio of the Value added (constant 2005 US$) in Timor-Leste in 2000 to that in 2003?
Give a very brief answer. 0.86. What is the ratio of the Value added (constant 2005 US$) in France in 2000 to that in 2004?
Your response must be concise. 0.93. What is the ratio of the Value added (constant 2005 US$) in Morocco in 2000 to that in 2004?
Provide a short and direct response. 0.85. What is the ratio of the Value added (constant 2005 US$) of Solomon Islands in 2000 to that in 2004?
Offer a very short reply. 1.15. What is the ratio of the Value added (constant 2005 US$) of Timor-Leste in 2000 to that in 2004?
Make the answer very short. 0.83. What is the ratio of the Value added (constant 2005 US$) in France in 2000 to that in 2005?
Make the answer very short. 0.92. What is the ratio of the Value added (constant 2005 US$) in Morocco in 2000 to that in 2005?
Your answer should be very brief. 0.79. What is the ratio of the Value added (constant 2005 US$) of Solomon Islands in 2000 to that in 2005?
Ensure brevity in your answer.  1.07. What is the ratio of the Value added (constant 2005 US$) in Timor-Leste in 2000 to that in 2005?
Provide a succinct answer. 0.76. What is the ratio of the Value added (constant 2005 US$) of France in 2000 to that in 2006?
Offer a terse response. 0.9. What is the ratio of the Value added (constant 2005 US$) in Morocco in 2000 to that in 2006?
Provide a short and direct response. 0.76. What is the ratio of the Value added (constant 2005 US$) of Solomon Islands in 2000 to that in 2006?
Ensure brevity in your answer.  0.99. What is the ratio of the Value added (constant 2005 US$) in Timor-Leste in 2000 to that in 2006?
Your response must be concise. 0.78. What is the ratio of the Value added (constant 2005 US$) of France in 2001 to that in 2002?
Your answer should be very brief. 0.99. What is the ratio of the Value added (constant 2005 US$) of Morocco in 2001 to that in 2002?
Give a very brief answer. 0.98. What is the ratio of the Value added (constant 2005 US$) in Solomon Islands in 2001 to that in 2002?
Provide a succinct answer. 1.13. What is the ratio of the Value added (constant 2005 US$) in Timor-Leste in 2001 to that in 2002?
Provide a short and direct response. 1.12. What is the ratio of the Value added (constant 2005 US$) of France in 2001 to that in 2003?
Ensure brevity in your answer.  0.98. What is the ratio of the Value added (constant 2005 US$) of Morocco in 2001 to that in 2003?
Offer a very short reply. 0.95. What is the ratio of the Value added (constant 2005 US$) of Solomon Islands in 2001 to that in 2003?
Make the answer very short. 1.21. What is the ratio of the Value added (constant 2005 US$) in Morocco in 2001 to that in 2004?
Provide a short and direct response. 0.9. What is the ratio of the Value added (constant 2005 US$) in Solomon Islands in 2001 to that in 2004?
Your response must be concise. 1.09. What is the ratio of the Value added (constant 2005 US$) of Timor-Leste in 2001 to that in 2004?
Offer a very short reply. 1.08. What is the ratio of the Value added (constant 2005 US$) of France in 2001 to that in 2005?
Ensure brevity in your answer.  0.94. What is the ratio of the Value added (constant 2005 US$) in Morocco in 2001 to that in 2005?
Your answer should be compact. 0.84. What is the ratio of the Value added (constant 2005 US$) in Solomon Islands in 2001 to that in 2005?
Make the answer very short. 1.01. What is the ratio of the Value added (constant 2005 US$) in Timor-Leste in 2001 to that in 2005?
Provide a short and direct response. 0.99. What is the ratio of the Value added (constant 2005 US$) of France in 2001 to that in 2006?
Make the answer very short. 0.91. What is the ratio of the Value added (constant 2005 US$) of Morocco in 2001 to that in 2006?
Offer a terse response. 0.8. What is the ratio of the Value added (constant 2005 US$) of Solomon Islands in 2001 to that in 2006?
Make the answer very short. 0.94. What is the ratio of the Value added (constant 2005 US$) in Timor-Leste in 2001 to that in 2006?
Your response must be concise. 1.02. What is the ratio of the Value added (constant 2005 US$) of Morocco in 2002 to that in 2003?
Ensure brevity in your answer.  0.96. What is the ratio of the Value added (constant 2005 US$) of Solomon Islands in 2002 to that in 2003?
Your response must be concise. 1.07. What is the ratio of the Value added (constant 2005 US$) in Timor-Leste in 2002 to that in 2003?
Offer a very short reply. 1.01. What is the ratio of the Value added (constant 2005 US$) of France in 2002 to that in 2004?
Give a very brief answer. 0.96. What is the ratio of the Value added (constant 2005 US$) of Morocco in 2002 to that in 2004?
Offer a terse response. 0.92. What is the ratio of the Value added (constant 2005 US$) of Solomon Islands in 2002 to that in 2004?
Provide a short and direct response. 0.97. What is the ratio of the Value added (constant 2005 US$) in France in 2002 to that in 2005?
Offer a very short reply. 0.95. What is the ratio of the Value added (constant 2005 US$) in Morocco in 2002 to that in 2005?
Offer a terse response. 0.85. What is the ratio of the Value added (constant 2005 US$) of Solomon Islands in 2002 to that in 2005?
Provide a succinct answer. 0.9. What is the ratio of the Value added (constant 2005 US$) of Timor-Leste in 2002 to that in 2005?
Your response must be concise. 0.89. What is the ratio of the Value added (constant 2005 US$) of France in 2002 to that in 2006?
Your answer should be compact. 0.92. What is the ratio of the Value added (constant 2005 US$) of Morocco in 2002 to that in 2006?
Ensure brevity in your answer.  0.82. What is the ratio of the Value added (constant 2005 US$) in Solomon Islands in 2002 to that in 2006?
Provide a succinct answer. 0.83. What is the ratio of the Value added (constant 2005 US$) of Timor-Leste in 2002 to that in 2006?
Offer a very short reply. 0.92. What is the ratio of the Value added (constant 2005 US$) in France in 2003 to that in 2004?
Make the answer very short. 0.97. What is the ratio of the Value added (constant 2005 US$) in Morocco in 2003 to that in 2004?
Ensure brevity in your answer.  0.95. What is the ratio of the Value added (constant 2005 US$) in Solomon Islands in 2003 to that in 2004?
Your response must be concise. 0.9. What is the ratio of the Value added (constant 2005 US$) in Timor-Leste in 2003 to that in 2004?
Keep it short and to the point. 0.96. What is the ratio of the Value added (constant 2005 US$) in France in 2003 to that in 2005?
Your response must be concise. 0.96. What is the ratio of the Value added (constant 2005 US$) in Morocco in 2003 to that in 2005?
Provide a succinct answer. 0.88. What is the ratio of the Value added (constant 2005 US$) of Solomon Islands in 2003 to that in 2005?
Give a very brief answer. 0.83. What is the ratio of the Value added (constant 2005 US$) in Timor-Leste in 2003 to that in 2005?
Provide a short and direct response. 0.88. What is the ratio of the Value added (constant 2005 US$) of France in 2003 to that in 2006?
Provide a short and direct response. 0.93. What is the ratio of the Value added (constant 2005 US$) of Morocco in 2003 to that in 2006?
Keep it short and to the point. 0.85. What is the ratio of the Value added (constant 2005 US$) in Solomon Islands in 2003 to that in 2006?
Offer a very short reply. 0.77. What is the ratio of the Value added (constant 2005 US$) of Timor-Leste in 2003 to that in 2006?
Your answer should be compact. 0.91. What is the ratio of the Value added (constant 2005 US$) of Morocco in 2004 to that in 2005?
Offer a very short reply. 0.93. What is the ratio of the Value added (constant 2005 US$) in Solomon Islands in 2004 to that in 2005?
Your response must be concise. 0.92. What is the ratio of the Value added (constant 2005 US$) in Timor-Leste in 2004 to that in 2005?
Your answer should be very brief. 0.92. What is the ratio of the Value added (constant 2005 US$) in France in 2004 to that in 2006?
Provide a short and direct response. 0.96. What is the ratio of the Value added (constant 2005 US$) in Morocco in 2004 to that in 2006?
Keep it short and to the point. 0.89. What is the ratio of the Value added (constant 2005 US$) of Solomon Islands in 2004 to that in 2006?
Your answer should be very brief. 0.86. What is the ratio of the Value added (constant 2005 US$) in Timor-Leste in 2004 to that in 2006?
Provide a succinct answer. 0.94. What is the ratio of the Value added (constant 2005 US$) in France in 2005 to that in 2006?
Your response must be concise. 0.97. What is the ratio of the Value added (constant 2005 US$) of Morocco in 2005 to that in 2006?
Provide a succinct answer. 0.96. What is the ratio of the Value added (constant 2005 US$) in Solomon Islands in 2005 to that in 2006?
Ensure brevity in your answer.  0.93. What is the ratio of the Value added (constant 2005 US$) in Timor-Leste in 2005 to that in 2006?
Provide a short and direct response. 1.03. What is the difference between the highest and the second highest Value added (constant 2005 US$) in France?
Offer a very short reply. 3.91e+1. What is the difference between the highest and the second highest Value added (constant 2005 US$) in Morocco?
Provide a short and direct response. 1.18e+09. What is the difference between the highest and the second highest Value added (constant 2005 US$) in Solomon Islands?
Your answer should be very brief. 3.08e+06. What is the difference between the highest and the second highest Value added (constant 2005 US$) in Timor-Leste?
Make the answer very short. 1.53e+06. What is the difference between the highest and the lowest Value added (constant 2005 US$) in France?
Keep it short and to the point. 1.61e+11. What is the difference between the highest and the lowest Value added (constant 2005 US$) in Morocco?
Your response must be concise. 7.53e+09. What is the difference between the highest and the lowest Value added (constant 2005 US$) in Solomon Islands?
Give a very brief answer. 5.72e+07. What is the difference between the highest and the lowest Value added (constant 2005 US$) of Timor-Leste?
Provide a succinct answer. 7.10e+07. 